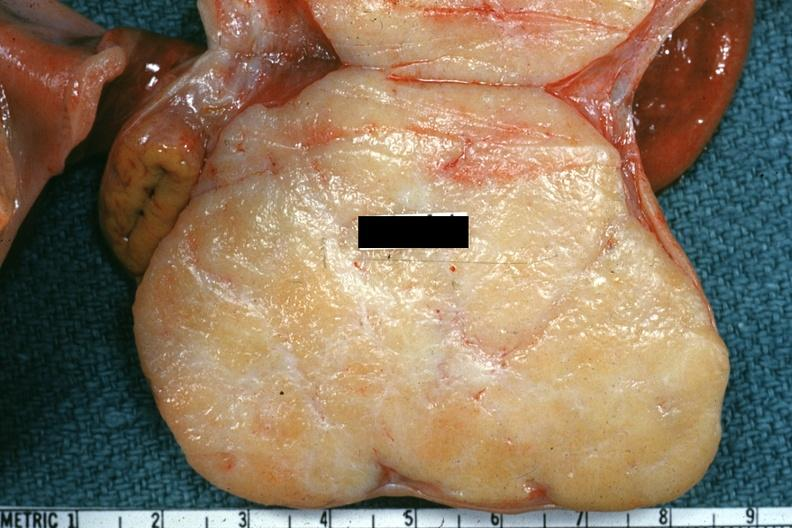where does this belong to?
Answer the question using a single word or phrase. Female reproductive system 